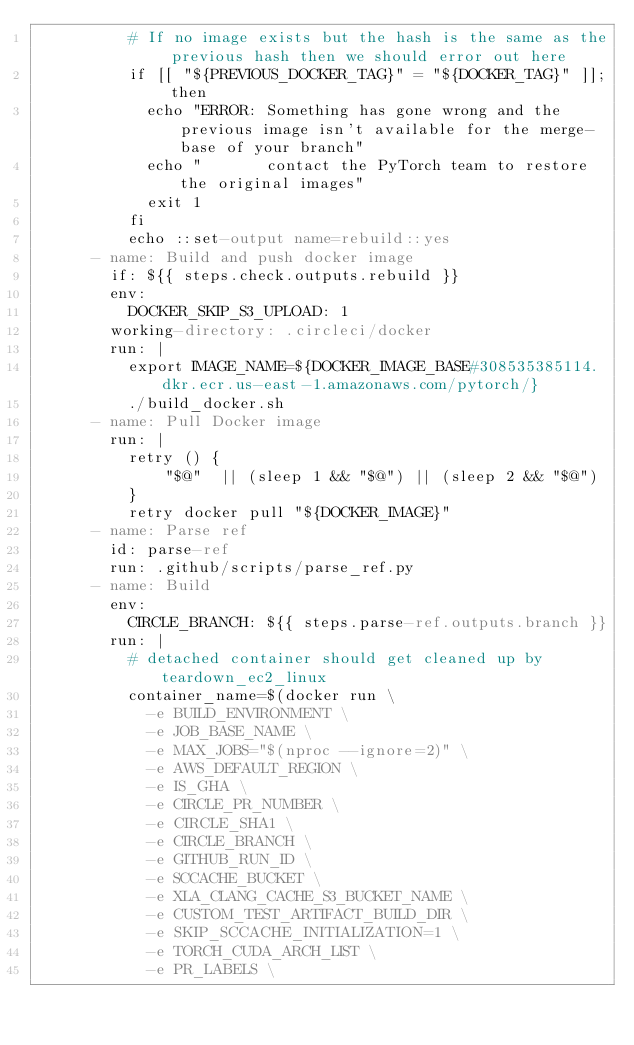<code> <loc_0><loc_0><loc_500><loc_500><_YAML_>          # If no image exists but the hash is the same as the previous hash then we should error out here
          if [[ "${PREVIOUS_DOCKER_TAG}" = "${DOCKER_TAG}" ]]; then
            echo "ERROR: Something has gone wrong and the previous image isn't available for the merge-base of your branch"
            echo "       contact the PyTorch team to restore the original images"
            exit 1
          fi
          echo ::set-output name=rebuild::yes
      - name: Build and push docker image
        if: ${{ steps.check.outputs.rebuild }}
        env:
          DOCKER_SKIP_S3_UPLOAD: 1
        working-directory: .circleci/docker
        run: |
          export IMAGE_NAME=${DOCKER_IMAGE_BASE#308535385114.dkr.ecr.us-east-1.amazonaws.com/pytorch/}
          ./build_docker.sh
      - name: Pull Docker image
        run: |
          retry () {
              "$@"  || (sleep 1 && "$@") || (sleep 2 && "$@")
          }
          retry docker pull "${DOCKER_IMAGE}"
      - name: Parse ref
        id: parse-ref
        run: .github/scripts/parse_ref.py
      - name: Build
        env:
          CIRCLE_BRANCH: ${{ steps.parse-ref.outputs.branch }}
        run: |
          # detached container should get cleaned up by teardown_ec2_linux
          container_name=$(docker run \
            -e BUILD_ENVIRONMENT \
            -e JOB_BASE_NAME \
            -e MAX_JOBS="$(nproc --ignore=2)" \
            -e AWS_DEFAULT_REGION \
            -e IS_GHA \
            -e CIRCLE_PR_NUMBER \
            -e CIRCLE_SHA1 \
            -e CIRCLE_BRANCH \
            -e GITHUB_RUN_ID \
            -e SCCACHE_BUCKET \
            -e XLA_CLANG_CACHE_S3_BUCKET_NAME \
            -e CUSTOM_TEST_ARTIFACT_BUILD_DIR \
            -e SKIP_SCCACHE_INITIALIZATION=1 \
            -e TORCH_CUDA_ARCH_LIST \
            -e PR_LABELS \</code> 